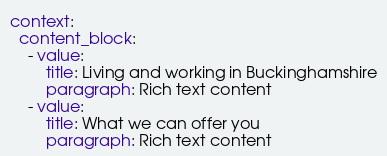Convert code to text. <code><loc_0><loc_0><loc_500><loc_500><_YAML_>context:
  content_block:
    - value:
        title: Living and working in Buckinghamshire
        paragraph: Rich text content
    - value:
        title: What we can offer you
        paragraph: Rich text content
</code> 